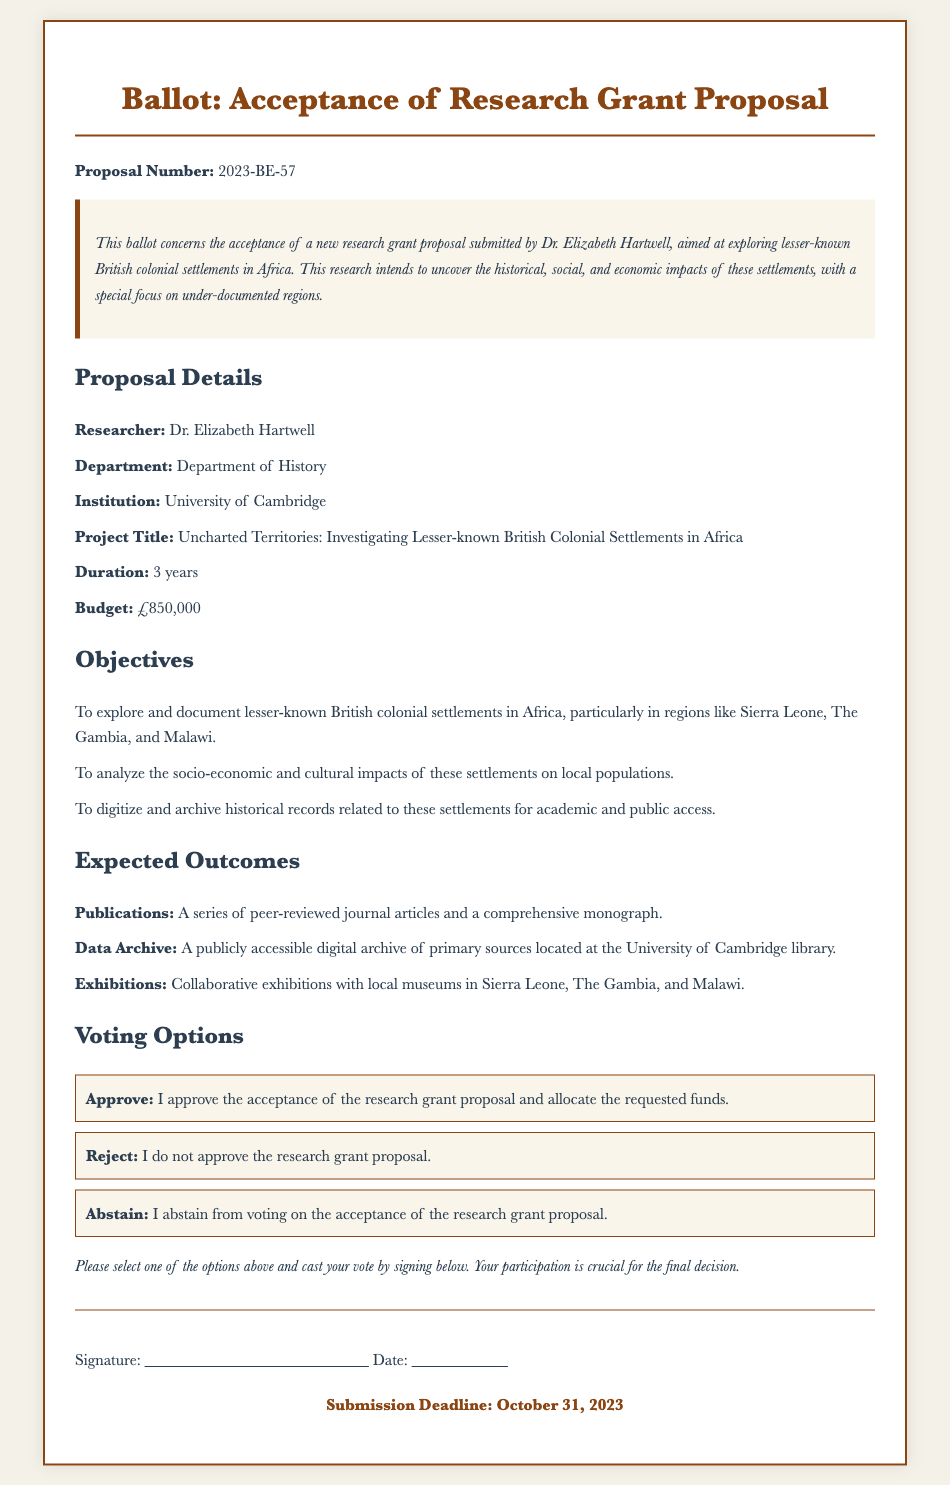What is the proposal number? The proposal number is a specific identifier for the research grant proposal mentioned in the document.
Answer: 2023-BE-57 Who is the researcher? The researcher is the individual who submitted the grant proposal and is leading the project detailed in the document.
Answer: Dr. Elizabeth Hartwell What is the budget for the project? The budget is the total amount of money requested for the research project as specified in the document.
Answer: £850,000 What is the duration of the research project? The duration indicates the time period over which the research will be conducted, according to the proposal details.
Answer: 3 years What is one of the objectives of the research? This question seeks one specific goal that the research aims to achieve, as outlined in the objectives section.
Answer: To explore and document lesser-known British colonial settlements in Africa How many expected publications are mentioned? This question is focused on the expected outcomes section, specifically the number of publications related to the research project.
Answer: A series What type of archive will be created? The question is about the kind of archive mentioned in the expected outcomes and what it will focus on.
Answer: A publicly accessible digital archive What is the main project title? The project title gives a succinct description of the research focus, as stated in the proposal details section.
Answer: Uncharted Territories: Investigating Lesser-known British Colonial Settlements in Africa What is the deadline for submission? The deadline indicates the final date by which votes must be submitted for the grant proposal decision.
Answer: October 31, 2023 